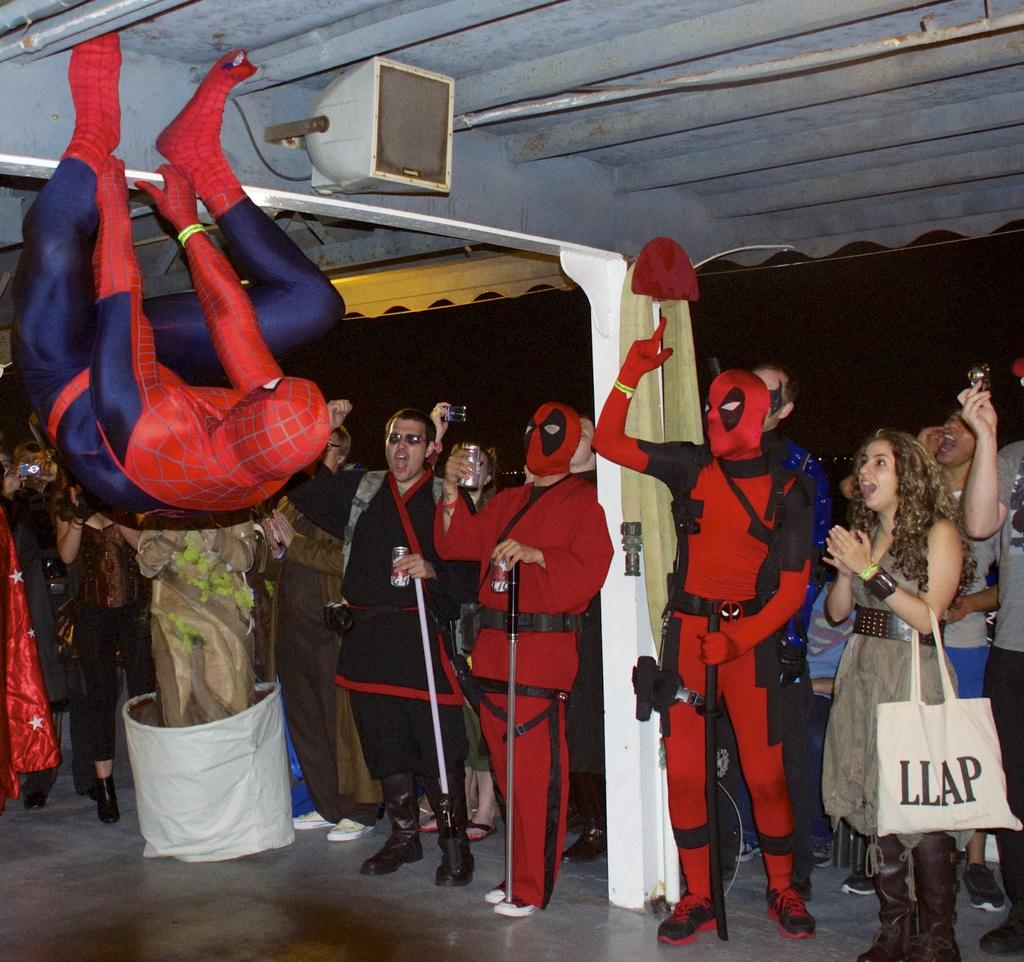What can be seen in the foreground of the image? In the foreground of the image, there are people in costumes standing on the floor and people cheering. What is located in the top part of the image? In the top part of the image, there is a shed and a speaker box. How many icicles are hanging from the coat of the person in the image? There are no icicles or coats present in the image. What type of secretary can be seen working in the shed in the image? There is no secretary or shed depicted in the image; it features people in costumes and people cheering in the foreground, and a shed and speaker box in the top part of the image. 